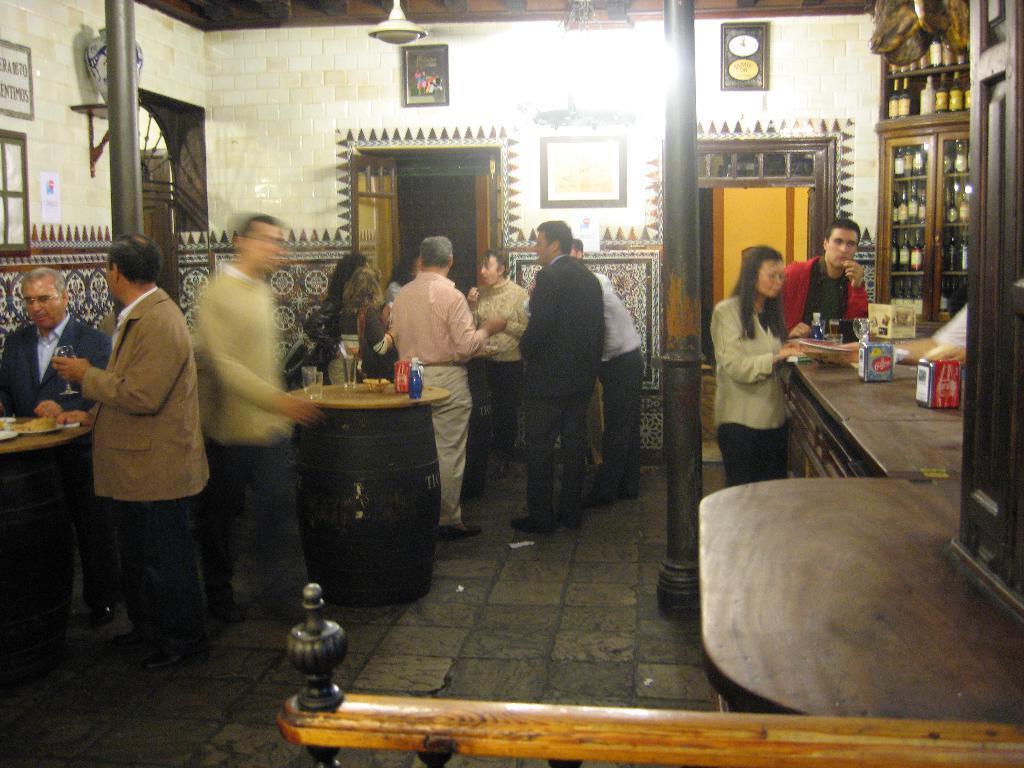Could you give a brief overview of what you see in this image? In this picture there are a group of people Standing and in the right side there is a table and there some wine bottles arranged in the shelf 